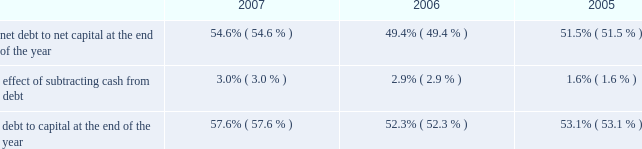E nt e r g y c o r p o r a t i o n a n d s u b s i d i a r i e s 2 0 0 7 n an increase of $ 16 million in fossil operating costs due to the purchase of the attala plant in january 2006 and the perryville plant coming online in july 2005 ; n an increase of $ 12 million related to storm reserves .
This increase does not include costs associated with hurricanes katrina and rita ; and n an increase of $ 12 million due to a return to normal expense patterns in 2006 versus the deferral or capitalization of storm costs in 2005 .
Other operation and maintenance expenses increased for non- utility nuclear from $ 588 million in 2005 to $ 637 million in 2006 primarily due to the timing of refueling outages , increased benefit and insurance costs , and increased nrc fees .
Taxes other than income taxes taxes other than income taxes increased for the utility from $ 322 million in 2005 to $ 361 million in 2006 primarily due to an increase in city franchise taxes in arkansas due to a change in 2006 in the accounting for city franchise tax revenues as directed by the apsc .
The change results in an increase in taxes other than income taxes with a corresponding increase in rider revenue , resulting in no effect on net income .
Also contributing to the increase was higher franchise tax expense at entergy gulf states , inc .
As a result of higher gross revenues in 2006 and a customer refund in 2005 .
Other income other income increased for the utility from $ 111 million in 2005 to $ 156 million in 2006 primarily due to carrying charges recorded on storm restoration costs .
Other income increased for non-utility nuclear primarily due to miscellaneous income of $ 27 million ( $ 16.6 million net-of-tax ) resulting from a reduction in the decommissioning liability for a plant as a result of a revised decommissioning cost study and changes in assumptions regarding the timing of when decommissioning of a plant will begin .
Other income increased for parent & other primarily due to a gain related to its entergy-koch investment of approximately $ 55 million ( net-of-tax ) in the fourth quarter of 2006 .
In 2004 , entergy-koch sold its energy trading and pipeline businesses to third parties .
At that time , entergy received $ 862 million of the sales proceeds in the form of a cash distribution by entergy-koch .
Due to the november 2006 expiration of contingencies on the sale of entergy-koch 2019s trading business , and the corresponding release to entergy-koch of sales proceeds held in escrow , entergy received additional cash distributions of approximately $ 163 million during the fourth quarter of 2006 and recorded a gain of approximately $ 55 million ( net-of-tax ) .
Entergy expects future cash distributions upon liquidation of the partnership will be less than $ 35 million .
Interest charges interest charges increased for the utility and parent & other primarily due to additional borrowing to fund the significant storm restoration costs associated with hurricanes katrina and rita .
Discontinued operations in april 2006 , entergy sold the retail electric portion of the competitive retail services business operating in the electric reliability council of texas ( ercot ) region of texas , and now reports this portion of the business as a discontinued operation .
Earnings for 2005 were negatively affected by $ 44.8 million ( net-of-tax ) of discontinued operations due to the planned sale .
This amount includes a net charge of $ 25.8 million ( net-of-tax ) related to the impairment reserve for the remaining net book value of the competitive retail services business 2019 information technology systems .
Results for 2006 include an $ 11.1 million gain ( net-of-tax ) on the sale of the retail electric portion of the competitive retail services business operating in the ercot region of texas .
Income taxes the effective income tax rates for 2006 and 2005 were 27.6% ( 27.6 % ) and 36.6% ( 36.6 % ) , respectively .
The lower effective income tax rate in 2006 is primarily due to tax benefits , net of reserves , resulting from the tax capital loss recognized in connection with the liquidation of entergy power international holdings , entergy 2019s holding company for entergy-koch .
Also contributing to the lower rate for 2006 is an irs audit settlement that allowed entergy to release from its tax reserves all settled issues relating to 1996-1998 audit cycle .
See note 3 to the financial statements for a reconciliation of the federal statutory rate of 35.0% ( 35.0 % ) to the effective income tax rates , and for additional discussion regarding income taxes .
Liquidity and capital resources this section discusses entergy 2019s capital structure , capital spending plans and other uses of capital , sources of capital , and the cash flow activity presented in the cash flow statement .
Capital structure entergy 2019s capitalization is balanced between equity and debt , as shown in the table .
The increase in the debt to capital percentage from 2006 to 2007 is primarily the result of additional borrowings under entergy corporation 2019s revolving credit facility , along with a decrease in shareholders 2019 equity primarily due to repurchases of common stock .
This increase in the debt to capital percentage is in line with entergy 2019s financial and risk management aspirations .
The decrease in the debt to capital percentage from 2005 to 2006 is the result of an increase in shareholders 2019 equity , primarily due to an increase in retained earnings , partially offset by repurchases of common stock. .
Net debt consists of debt less cash and cash equivalents .
Debt consists of notes payable , capital lease obligations , preferred stock with sinking fund , and long-term debt , including the currently maturing portion .
Capital consists of debt , shareholders 2019 equity , and preferred stock without sinking fund .
Net capital consists of capital less cash and cash equivalents .
Entergy uses the net debt to net capital ratio in analyzing its financial condition and believes it provides useful information to its investors and creditors in evaluating entergy 2019s financial condition .
M an ag e ment 2019s f i n anc ial d i scuss ion an d an alys is co n t i n u e d .
What is the growth rate of debt to capital ratio from 2006 to 2007? 
Computations: ((57.6 - 52.3) / 52.3)
Answer: 0.10134. 